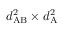Convert formula to latex. <formula><loc_0><loc_0><loc_500><loc_500>d _ { A B } ^ { 2 } \times d _ { A } ^ { 2 }</formula> 